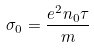Convert formula to latex. <formula><loc_0><loc_0><loc_500><loc_500>\sigma _ { 0 } = \frac { e ^ { 2 } n _ { 0 } \tau } { m }</formula> 